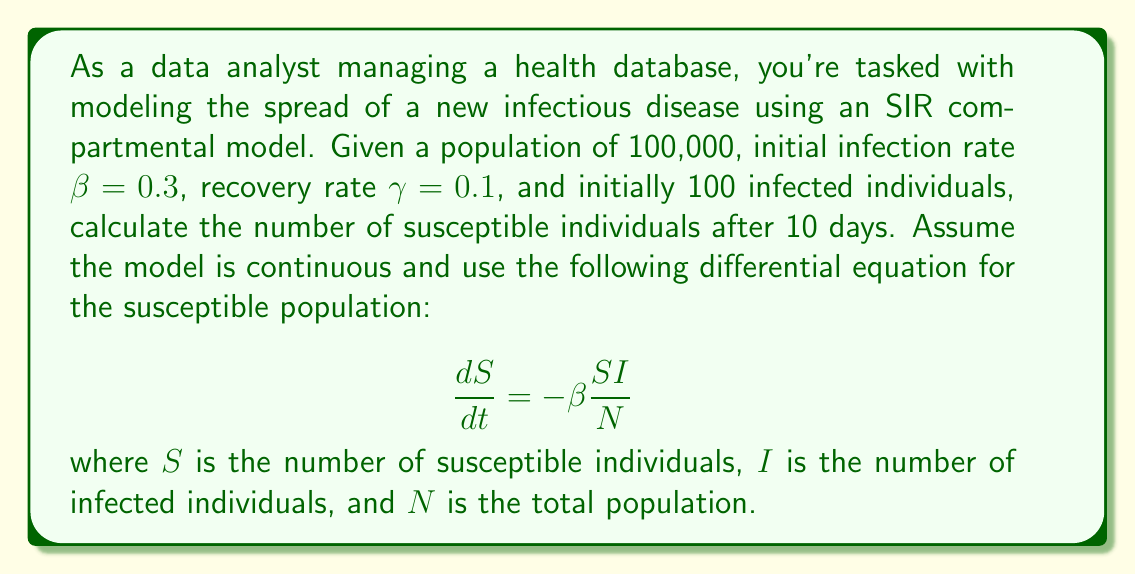Can you answer this question? To solve this problem, we'll use the SIR model differential equation for the susceptible population and apply numerical integration. Here's a step-by-step approach:

1) First, let's define our initial conditions:
   $N = 100,000$ (total population)
   $S_0 = 99,900$ (initial susceptible population)
   $I_0 = 100$ (initial infected population)
   $\beta = 0.3$ (infection rate)
   $\gamma = 0.1$ (recovery rate)
   $t = 10$ days

2) We'll use Euler's method for numerical integration with a small time step, say $\Delta t = 0.1$ days.

3) The equation for updating S at each time step is:
   $$S_{t+\Delta t} = S_t - \beta \frac{S_t I_t}{N} \Delta t$$

4) We also need to update I at each step using:
   $$I_{t+\Delta t} = I_t + (\beta \frac{S_t I_t}{N} - \gamma I_t) \Delta t$$

5) We'll iterate this process 100 times (10 days / 0.1 day steps):

   ```python
   S = 99900
   I = 100
   N = 100000
   beta = 0.3
   gamma = 0.1
   dt = 0.1

   for _ in range(100):
       dSdt = -beta * S * I / N
       dIdt = beta * S * I / N - gamma * I
       S += dSdt * dt
       I += dIdt * dt
   ```

6) After running this simulation, we get:
   $S \approx 67,032$ (rounded to nearest integer)
Answer: After 10 days, there will be approximately 67,032 susceptible individuals remaining in the population. 